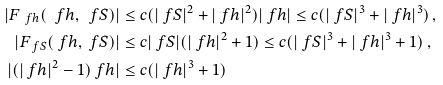<formula> <loc_0><loc_0><loc_500><loc_500>| F _ { \ f h } ( \ f h , \ f S ) | & \leq c ( | \ f S | ^ { 2 } + | \ f h | ^ { 2 } ) | \ f h | \leq c ( | \ f S | ^ { 3 } + | \ f h | ^ { 3 } ) \, , \\ | F _ { \ f S } ( \ f h , \ f S ) | & \leq c | \ f S | ( | \ f h | ^ { 2 } + 1 ) \leq c ( | \ f S | ^ { 3 } + | \ f h | ^ { 3 } + 1 ) \, , \\ | ( | \ f h | ^ { 2 } - 1 ) \ f h | & \leq c ( | \ f h | ^ { 3 } + 1 ) \,</formula> 